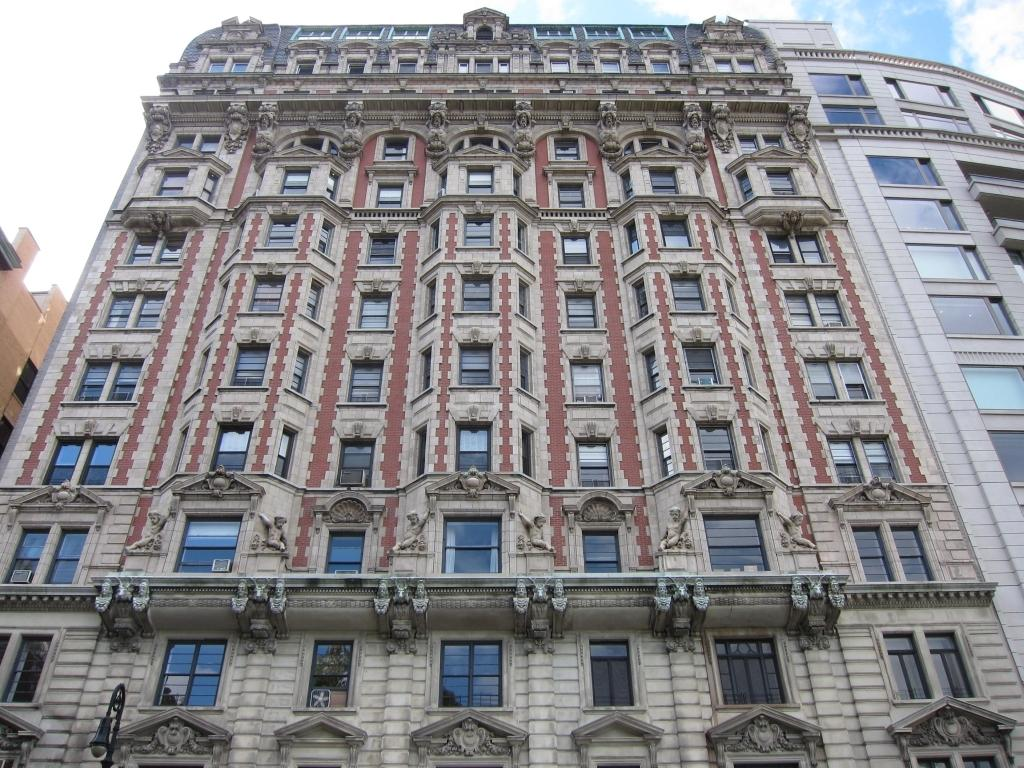What type of structure is present in the image? There is a building in the image. What can be seen in the background of the image? The sky is visible at the top of the image. What role does the actor play in the image? There is no actor present in the image; it only features a building and the sky. What tool is being used to construct the building in the image? There is no construction or tool visible in the image; it only shows a building and the sky. 